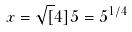<formula> <loc_0><loc_0><loc_500><loc_500>x = \sqrt { [ } 4 ] { 5 } = 5 ^ { 1 / 4 }</formula> 